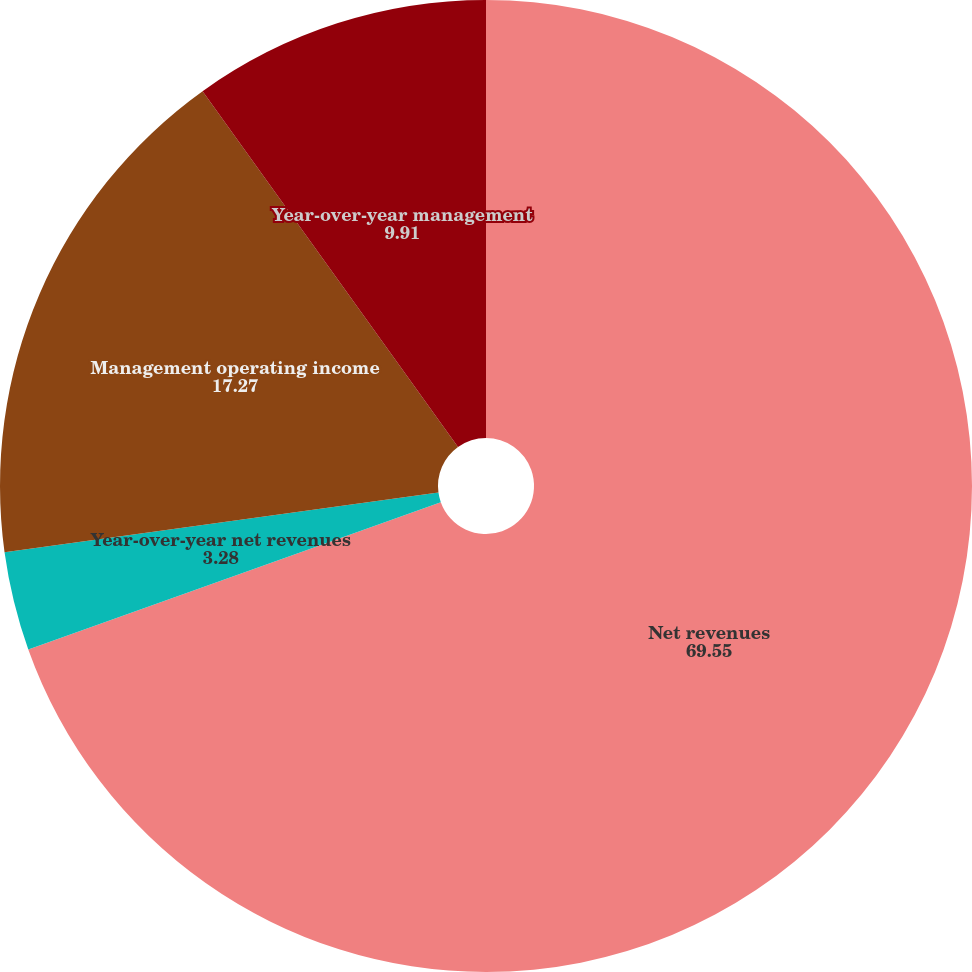<chart> <loc_0><loc_0><loc_500><loc_500><pie_chart><fcel>Net revenues<fcel>Year-over-year net revenues<fcel>Management operating income<fcel>Year-over-year management<nl><fcel>69.55%<fcel>3.28%<fcel>17.27%<fcel>9.91%<nl></chart> 